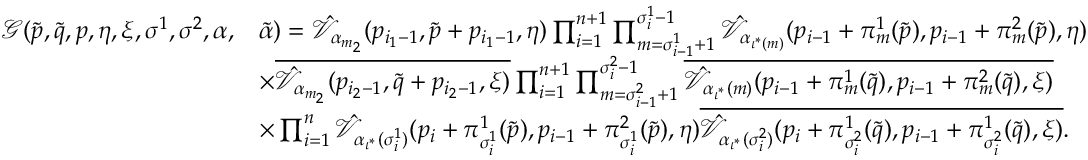Convert formula to latex. <formula><loc_0><loc_0><loc_500><loc_500>\begin{array} { r l } { \mathcal { G } ( \tilde { p } , \tilde { q } , p , \eta , \xi , \sigma ^ { 1 } , \sigma ^ { 2 } , \alpha , } & { \tilde { \alpha } ) = \hat { \mathcal { V } } _ { \alpha _ { m _ { 2 } } } ( p _ { i _ { 1 } - 1 } , \tilde { p } + p _ { i _ { 1 } - 1 } , \eta ) \prod _ { i = 1 } ^ { n + 1 } \prod _ { m = \sigma _ { i - 1 } ^ { 1 } + 1 } ^ { \sigma _ { i } ^ { 1 } - 1 } \hat { \mathcal { V } } _ { \alpha _ { \iota ^ { * } ( m ) } } ( p _ { i - 1 } + \pi _ { m } ^ { 1 } ( \tilde { p } ) , p _ { i - 1 } + \pi _ { m } ^ { 2 } ( \tilde { p } ) , \eta ) } \\ & { \times \overline { { \hat { \mathcal { V } } _ { \alpha _ { m _ { 2 } } } ( p _ { i _ { 2 } - 1 } , \tilde { q } + p _ { i _ { 2 } - 1 } , \xi ) } } \prod _ { i = 1 } ^ { n + 1 } \prod _ { m = \sigma _ { i - 1 } ^ { 2 } + 1 } ^ { \sigma _ { i } ^ { 2 } - 1 } \overline { { \hat { \mathcal { V } } _ { \alpha _ { \iota ^ { * } } ( m ) } ( p _ { i - 1 } + \pi _ { m } ^ { 1 } ( \tilde { q } ) , p _ { i - 1 } + \pi _ { m } ^ { 2 } ( \tilde { q } ) , \xi ) } } } \\ & { \times \prod _ { i = 1 } ^ { n } \hat { \mathcal { V } } _ { \alpha _ { \iota ^ { * } } ( \sigma _ { i } ^ { 1 } ) } ( p _ { i } + \pi _ { \sigma _ { i } ^ { 1 } } ^ { 1 } ( \tilde { p } ) , p _ { i - 1 } + \pi _ { \sigma _ { i } ^ { 1 } } ^ { 2 } ( \tilde { p } ) , \eta ) \overline { { \hat { \mathcal { V } } _ { \alpha _ { \iota ^ { * } } ( \sigma _ { i } ^ { 2 } ) } ( p _ { i } + \pi _ { \sigma _ { i } ^ { 2 } } ^ { 1 } ( \tilde { q } ) , p _ { i - 1 } + \pi _ { \sigma _ { i } ^ { 2 } } ^ { 1 } ( \tilde { q } ) , \xi ) } } . } \end{array}</formula> 